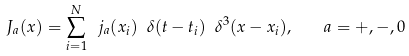Convert formula to latex. <formula><loc_0><loc_0><loc_500><loc_500>J _ { a } ( x ) = \sum ^ { N } _ { i = 1 } \ j _ { a } ( x _ { i } ) \ \delta ( t - t _ { i } ) \ \delta ^ { 3 } ( { x } - { x } _ { i } ) , \quad a = + , - , 0</formula> 